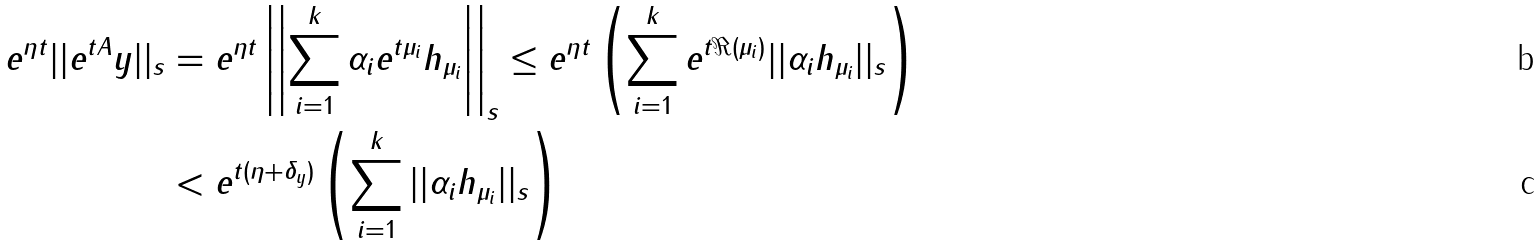<formula> <loc_0><loc_0><loc_500><loc_500>e ^ { \eta t } | | e ^ { t A } y | | _ { s } & = e ^ { \eta t } \left | \left | \sum _ { i = 1 } ^ { k } \alpha _ { i } e ^ { t \mu _ { i } } h _ { \mu _ { i } } \right | \right | _ { s } \leq e ^ { \eta t } \left ( \sum _ { i = 1 } ^ { k } e ^ { t \Re ( \mu _ { i } ) } | | \alpha _ { i } h _ { \mu _ { i } } | | _ { s } \right ) \\ & < e ^ { t ( \eta + \delta _ { y } ) } \left ( \sum _ { i = 1 } ^ { k } | | \alpha _ { i } h _ { \mu _ { i } } | | _ { s } \right )</formula> 